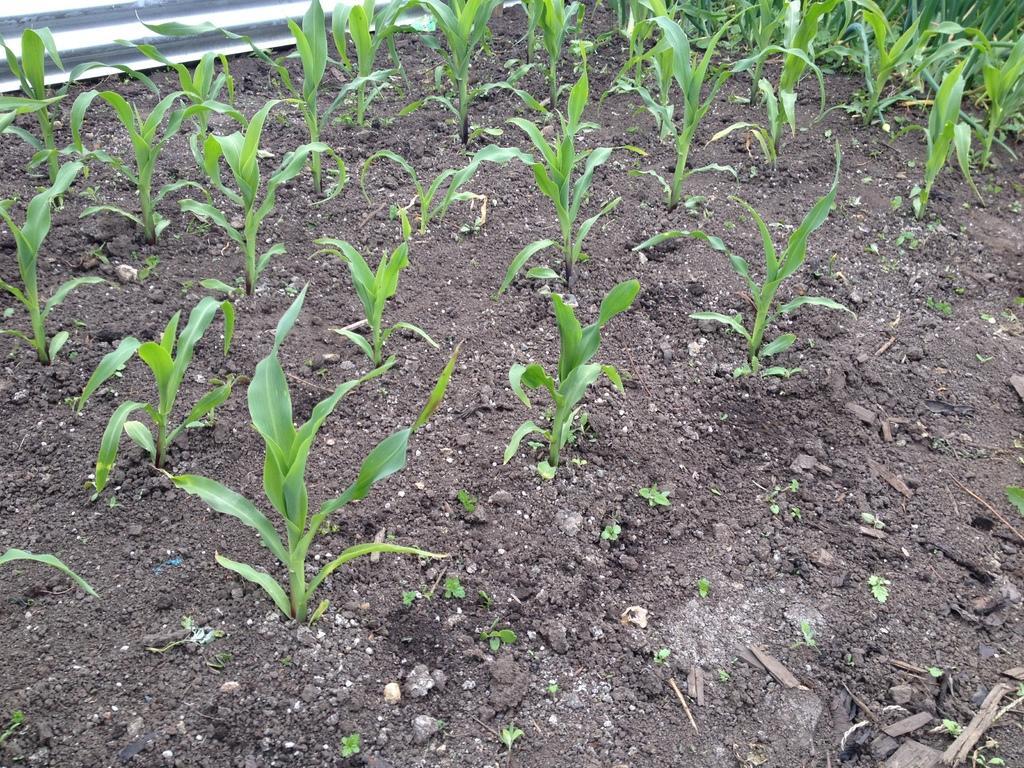Could you give a brief overview of what you see in this image? Here in this picture we can see some plants present on the ground over there. 